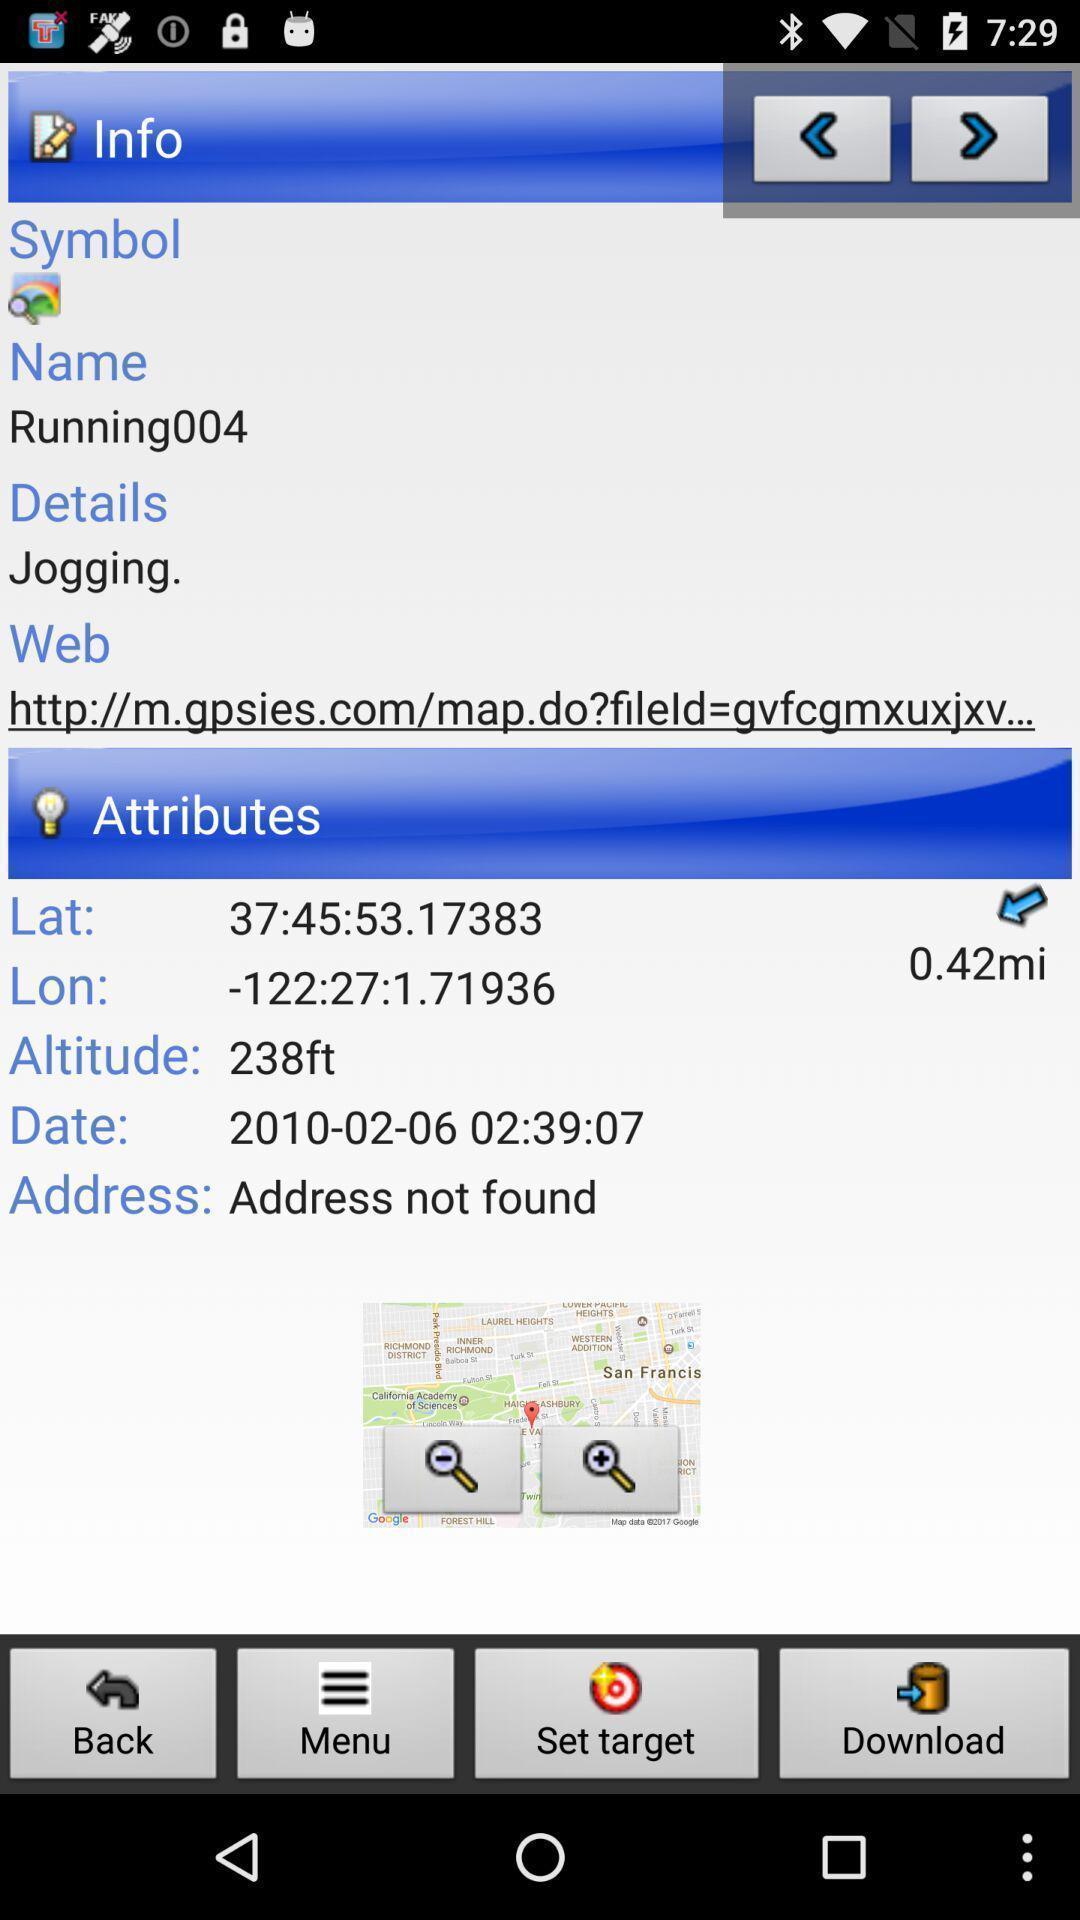Give me a summary of this screen capture. Page showing information about attributes and info. 